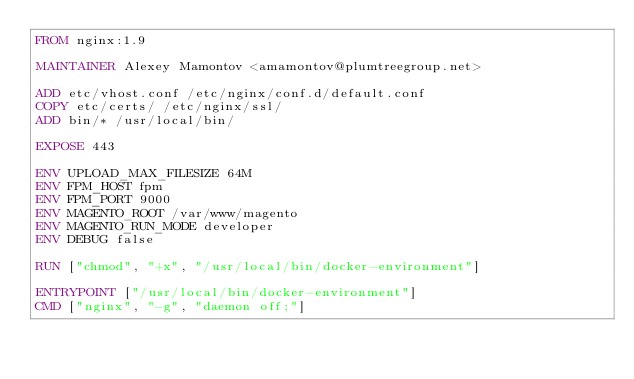<code> <loc_0><loc_0><loc_500><loc_500><_Dockerfile_>FROM nginx:1.9

MAINTAINER Alexey Mamontov <amamontov@plumtreegroup.net>

ADD etc/vhost.conf /etc/nginx/conf.d/default.conf
COPY etc/certs/ /etc/nginx/ssl/
ADD bin/* /usr/local/bin/

EXPOSE 443

ENV UPLOAD_MAX_FILESIZE 64M
ENV FPM_HOST fpm
ENV FPM_PORT 9000
ENV MAGENTO_ROOT /var/www/magento
ENV MAGENTO_RUN_MODE developer
ENV DEBUG false

RUN ["chmod", "+x", "/usr/local/bin/docker-environment"]

ENTRYPOINT ["/usr/local/bin/docker-environment"]
CMD ["nginx", "-g", "daemon off;"]
</code> 